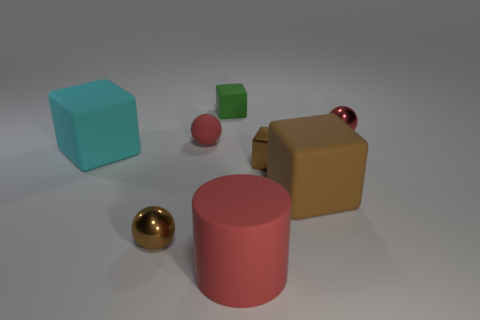Add 1 large brown rubber blocks. How many objects exist? 9 Subtract all red matte balls. How many balls are left? 2 Subtract all cylinders. How many objects are left? 7 Subtract 3 blocks. How many blocks are left? 1 Add 2 tiny red rubber objects. How many tiny red rubber objects are left? 3 Add 3 shiny things. How many shiny things exist? 6 Subtract all brown blocks. How many blocks are left? 2 Subtract 1 green cubes. How many objects are left? 7 Subtract all cyan cylinders. Subtract all gray blocks. How many cylinders are left? 1 Subtract all gray blocks. How many yellow cylinders are left? 0 